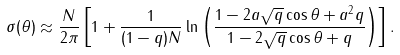<formula> <loc_0><loc_0><loc_500><loc_500>\sigma ( \theta ) \approx \frac { N } { 2 \pi } \left [ 1 + \frac { 1 } { ( 1 - q ) N } \ln \left ( \frac { 1 - 2 a \sqrt { q } \cos \theta + a ^ { 2 } q } { 1 - 2 \sqrt { q } \cos \theta + q } \right ) \right ] .</formula> 